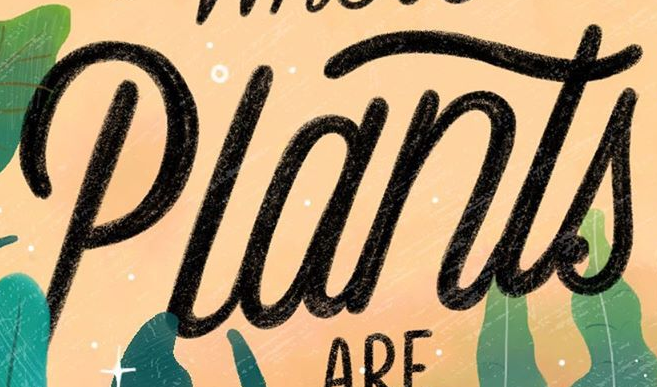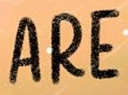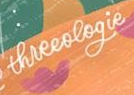What words can you see in these images in sequence, separated by a semicolon? Plants; ARE; threeologie 